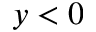<formula> <loc_0><loc_0><loc_500><loc_500>y < 0</formula> 